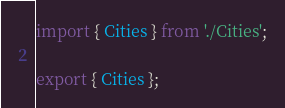<code> <loc_0><loc_0><loc_500><loc_500><_TypeScript_>import { Cities } from './Cities';

export { Cities };
</code> 